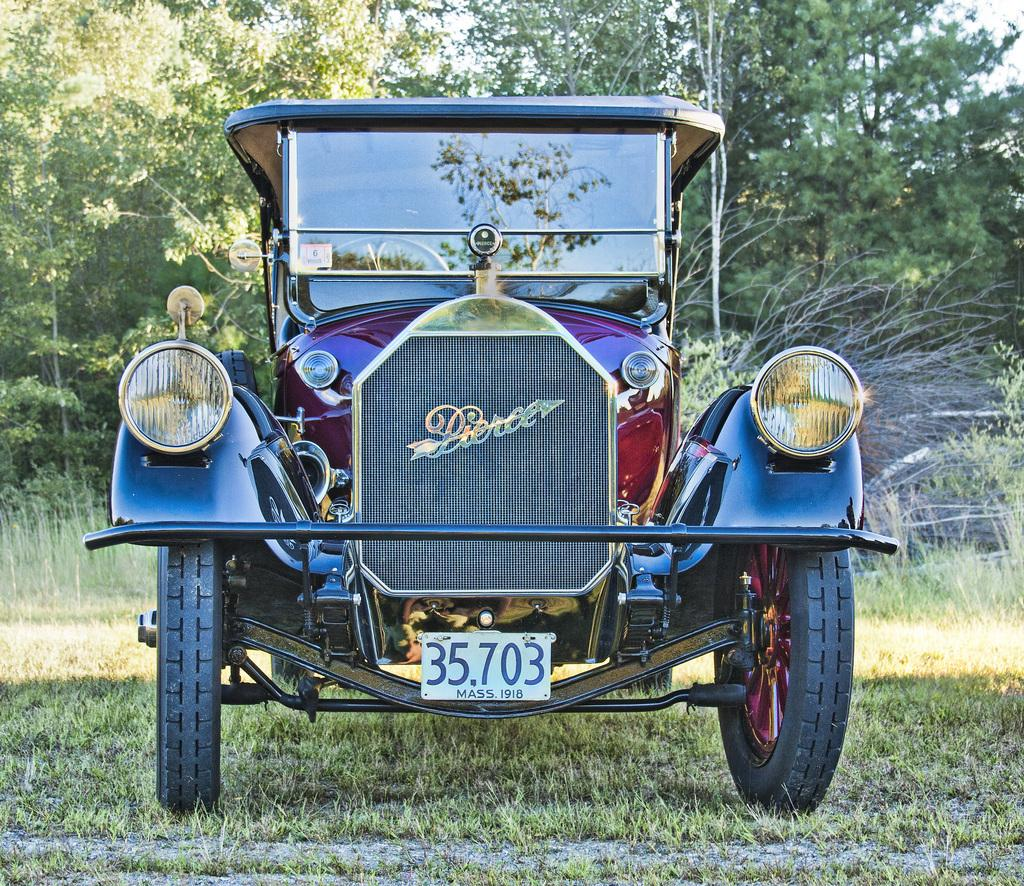What is the main subject of the image? The main subject of the image is a car. Where is the car located in the image? The car is on the surface of the grass. What can be seen in the background of the image? There are trees in the background of the image. How many chairs are placed around the maid in the image? There is no maid or chairs present in the image; it features a car on the grass with trees in the background. 